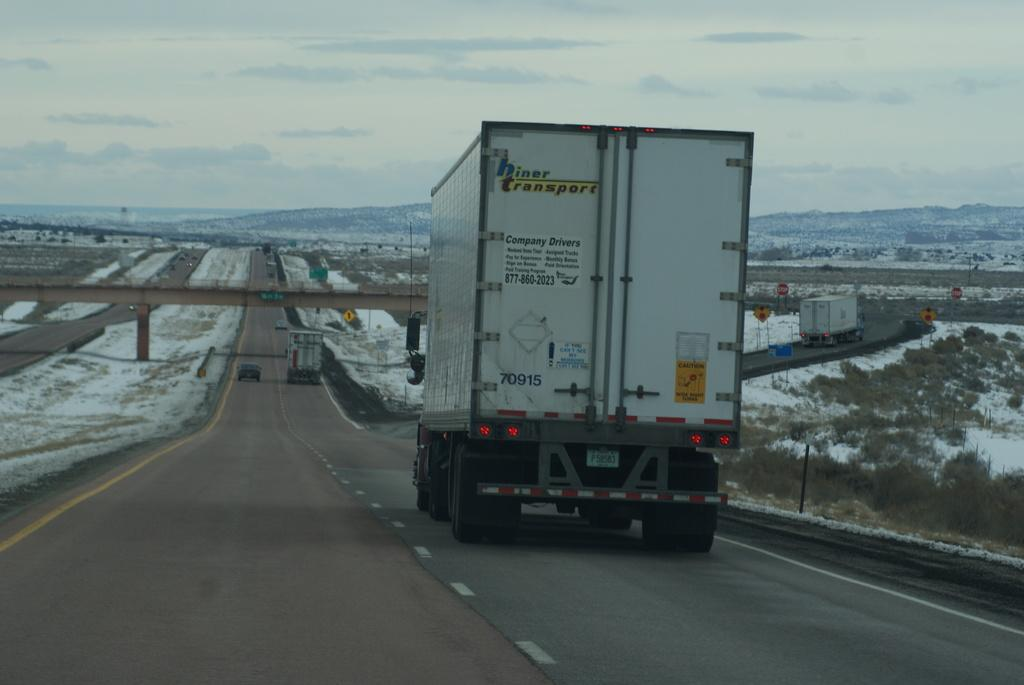What types of vehicles can be seen on the road in the image? There are trucks and cars on the road in the image. What structure is present in the image that allows vehicles to cross over a body of water or obstacle? There is a bridge in the image. What type of natural feature can be seen in the background of the image? There are hills visible in the background of the image. What part of the natural environment is visible in the background of the image? The sky is visible in the background of the image. What objects are present in the image that might be used for displaying information or advertisements? There are boards in the image. What type of stitch is being used to repair the drum in the image? There is no drum or stitching present in the image; it features trucks, cars, a bridge, hills, the sky, and boards. Who is the representative of the group in the image? There is no group or representative present in the image. 